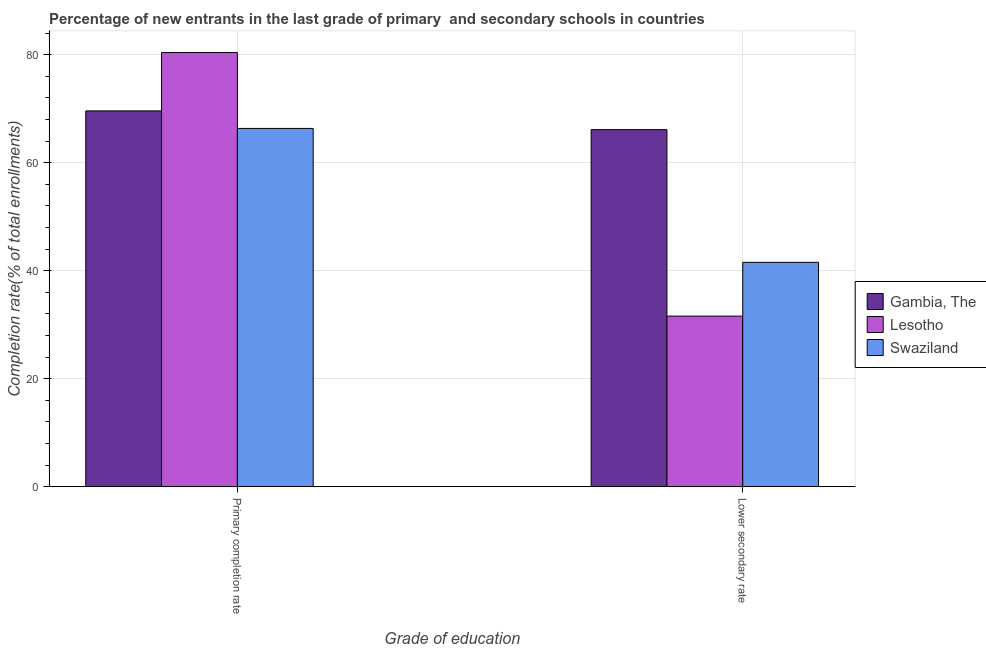Are the number of bars per tick equal to the number of legend labels?
Offer a terse response. Yes. Are the number of bars on each tick of the X-axis equal?
Offer a very short reply. Yes. How many bars are there on the 1st tick from the left?
Make the answer very short. 3. How many bars are there on the 1st tick from the right?
Your answer should be very brief. 3. What is the label of the 2nd group of bars from the left?
Your response must be concise. Lower secondary rate. What is the completion rate in primary schools in Lesotho?
Your answer should be compact. 80.39. Across all countries, what is the maximum completion rate in primary schools?
Your answer should be compact. 80.39. Across all countries, what is the minimum completion rate in secondary schools?
Keep it short and to the point. 31.59. In which country was the completion rate in secondary schools maximum?
Your response must be concise. Gambia, The. In which country was the completion rate in secondary schools minimum?
Offer a terse response. Lesotho. What is the total completion rate in primary schools in the graph?
Make the answer very short. 216.3. What is the difference between the completion rate in primary schools in Lesotho and that in Gambia, The?
Your answer should be very brief. 10.81. What is the difference between the completion rate in primary schools in Swaziland and the completion rate in secondary schools in Lesotho?
Make the answer very short. 34.74. What is the average completion rate in primary schools per country?
Provide a short and direct response. 72.1. What is the difference between the completion rate in primary schools and completion rate in secondary schools in Lesotho?
Keep it short and to the point. 48.8. What is the ratio of the completion rate in secondary schools in Lesotho to that in Swaziland?
Keep it short and to the point. 0.76. Is the completion rate in secondary schools in Lesotho less than that in Swaziland?
Provide a succinct answer. Yes. In how many countries, is the completion rate in primary schools greater than the average completion rate in primary schools taken over all countries?
Give a very brief answer. 1. What does the 2nd bar from the left in Primary completion rate represents?
Give a very brief answer. Lesotho. What does the 3rd bar from the right in Primary completion rate represents?
Offer a very short reply. Gambia, The. What is the difference between two consecutive major ticks on the Y-axis?
Offer a terse response. 20. Are the values on the major ticks of Y-axis written in scientific E-notation?
Offer a terse response. No. What is the title of the graph?
Offer a very short reply. Percentage of new entrants in the last grade of primary  and secondary schools in countries. Does "Ghana" appear as one of the legend labels in the graph?
Give a very brief answer. No. What is the label or title of the X-axis?
Your response must be concise. Grade of education. What is the label or title of the Y-axis?
Offer a very short reply. Completion rate(% of total enrollments). What is the Completion rate(% of total enrollments) of Gambia, The in Primary completion rate?
Ensure brevity in your answer.  69.58. What is the Completion rate(% of total enrollments) in Lesotho in Primary completion rate?
Make the answer very short. 80.39. What is the Completion rate(% of total enrollments) of Swaziland in Primary completion rate?
Offer a very short reply. 66.33. What is the Completion rate(% of total enrollments) in Gambia, The in Lower secondary rate?
Offer a terse response. 66.11. What is the Completion rate(% of total enrollments) in Lesotho in Lower secondary rate?
Provide a short and direct response. 31.59. What is the Completion rate(% of total enrollments) in Swaziland in Lower secondary rate?
Make the answer very short. 41.54. Across all Grade of education, what is the maximum Completion rate(% of total enrollments) of Gambia, The?
Make the answer very short. 69.58. Across all Grade of education, what is the maximum Completion rate(% of total enrollments) of Lesotho?
Ensure brevity in your answer.  80.39. Across all Grade of education, what is the maximum Completion rate(% of total enrollments) in Swaziland?
Ensure brevity in your answer.  66.33. Across all Grade of education, what is the minimum Completion rate(% of total enrollments) in Gambia, The?
Offer a very short reply. 66.11. Across all Grade of education, what is the minimum Completion rate(% of total enrollments) in Lesotho?
Provide a succinct answer. 31.59. Across all Grade of education, what is the minimum Completion rate(% of total enrollments) of Swaziland?
Offer a very short reply. 41.54. What is the total Completion rate(% of total enrollments) in Gambia, The in the graph?
Your response must be concise. 135.69. What is the total Completion rate(% of total enrollments) in Lesotho in the graph?
Provide a succinct answer. 111.98. What is the total Completion rate(% of total enrollments) of Swaziland in the graph?
Give a very brief answer. 107.88. What is the difference between the Completion rate(% of total enrollments) of Gambia, The in Primary completion rate and that in Lower secondary rate?
Your answer should be compact. 3.47. What is the difference between the Completion rate(% of total enrollments) of Lesotho in Primary completion rate and that in Lower secondary rate?
Offer a very short reply. 48.8. What is the difference between the Completion rate(% of total enrollments) of Swaziland in Primary completion rate and that in Lower secondary rate?
Provide a short and direct response. 24.79. What is the difference between the Completion rate(% of total enrollments) in Gambia, The in Primary completion rate and the Completion rate(% of total enrollments) in Lesotho in Lower secondary rate?
Your answer should be compact. 37.99. What is the difference between the Completion rate(% of total enrollments) of Gambia, The in Primary completion rate and the Completion rate(% of total enrollments) of Swaziland in Lower secondary rate?
Your answer should be compact. 28.04. What is the difference between the Completion rate(% of total enrollments) of Lesotho in Primary completion rate and the Completion rate(% of total enrollments) of Swaziland in Lower secondary rate?
Your answer should be very brief. 38.84. What is the average Completion rate(% of total enrollments) in Gambia, The per Grade of education?
Provide a short and direct response. 67.85. What is the average Completion rate(% of total enrollments) in Lesotho per Grade of education?
Keep it short and to the point. 55.99. What is the average Completion rate(% of total enrollments) in Swaziland per Grade of education?
Your response must be concise. 53.94. What is the difference between the Completion rate(% of total enrollments) in Gambia, The and Completion rate(% of total enrollments) in Lesotho in Primary completion rate?
Make the answer very short. -10.81. What is the difference between the Completion rate(% of total enrollments) of Gambia, The and Completion rate(% of total enrollments) of Swaziland in Primary completion rate?
Offer a very short reply. 3.25. What is the difference between the Completion rate(% of total enrollments) of Lesotho and Completion rate(% of total enrollments) of Swaziland in Primary completion rate?
Your answer should be compact. 14.05. What is the difference between the Completion rate(% of total enrollments) of Gambia, The and Completion rate(% of total enrollments) of Lesotho in Lower secondary rate?
Offer a very short reply. 34.52. What is the difference between the Completion rate(% of total enrollments) in Gambia, The and Completion rate(% of total enrollments) in Swaziland in Lower secondary rate?
Offer a terse response. 24.57. What is the difference between the Completion rate(% of total enrollments) in Lesotho and Completion rate(% of total enrollments) in Swaziland in Lower secondary rate?
Offer a very short reply. -9.95. What is the ratio of the Completion rate(% of total enrollments) of Gambia, The in Primary completion rate to that in Lower secondary rate?
Provide a succinct answer. 1.05. What is the ratio of the Completion rate(% of total enrollments) in Lesotho in Primary completion rate to that in Lower secondary rate?
Your response must be concise. 2.54. What is the ratio of the Completion rate(% of total enrollments) of Swaziland in Primary completion rate to that in Lower secondary rate?
Your answer should be very brief. 1.6. What is the difference between the highest and the second highest Completion rate(% of total enrollments) of Gambia, The?
Make the answer very short. 3.47. What is the difference between the highest and the second highest Completion rate(% of total enrollments) in Lesotho?
Your answer should be very brief. 48.8. What is the difference between the highest and the second highest Completion rate(% of total enrollments) in Swaziland?
Make the answer very short. 24.79. What is the difference between the highest and the lowest Completion rate(% of total enrollments) of Gambia, The?
Your answer should be very brief. 3.47. What is the difference between the highest and the lowest Completion rate(% of total enrollments) of Lesotho?
Give a very brief answer. 48.8. What is the difference between the highest and the lowest Completion rate(% of total enrollments) in Swaziland?
Your answer should be very brief. 24.79. 